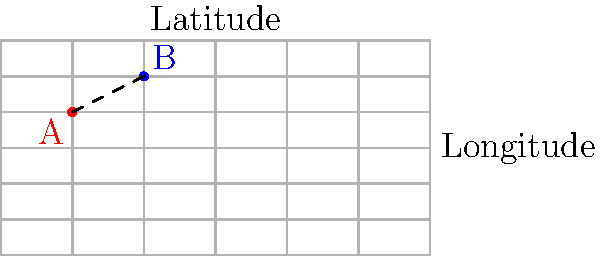As a travel agent organizing a fishing trip, you need to calculate the distance between two prime fishing spots. Spot A is located at coordinates (-120°, 30°) and Spot B is at (-60°, 60°). Using the Haversine formula for great-circle distance, calculate the approximate distance between these two spots in kilometers. Assume the Earth's radius is 6371 km. Round your answer to the nearest whole number. To calculate the distance between two points on a sphere (like Earth) using latitude and longitude coordinates, we can use the Haversine formula:

1) First, convert the latitudes and longitudes from degrees to radians:
   $\text{lat}_1 = 30° \times \frac{\pi}{180} = 0.5236$ rad
   $\text{lon}_1 = -120° \times \frac{\pi}{180} = -2.0944$ rad
   $\text{lat}_2 = 60° \times \frac{\pi}{180} = 1.0472$ rad
   $\text{lon}_2 = -60° \times \frac{\pi}{180} = -1.0472$ rad

2) Calculate the differences:
   $\Delta\text{lat} = \text{lat}_2 - \text{lat}_1 = 0.5236$ rad
   $\Delta\text{lon} = \text{lon}_2 - \text{lon}_1 = 1.0472$ rad

3) Apply the Haversine formula:
   $a = \sin^2(\frac{\Delta\text{lat}}{2}) + \cos(\text{lat}_1) \times \cos(\text{lat}_2) \times \sin^2(\frac{\Delta\text{lon}}{2})$
   
   $a = \sin^2(0.2618) + \cos(0.5236) \times \cos(1.0472) \times \sin^2(0.5236)$
   
   $a = 0.0681 + 0.8660 \times 0.5 \times 0.2630 = 0.1820$

4) Calculate the central angle:
   $c = 2 \times \arctan2(\sqrt{a}, \sqrt{1-a}) = 0.8805$ rad

5) Calculate the distance:
   $d = R \times c$, where $R$ is Earth's radius (6371 km)
   $d = 6371 \times 0.8805 = 5609.6$ km

6) Rounding to the nearest whole number:
   $d \approx 5610$ km
Answer: 5610 km 